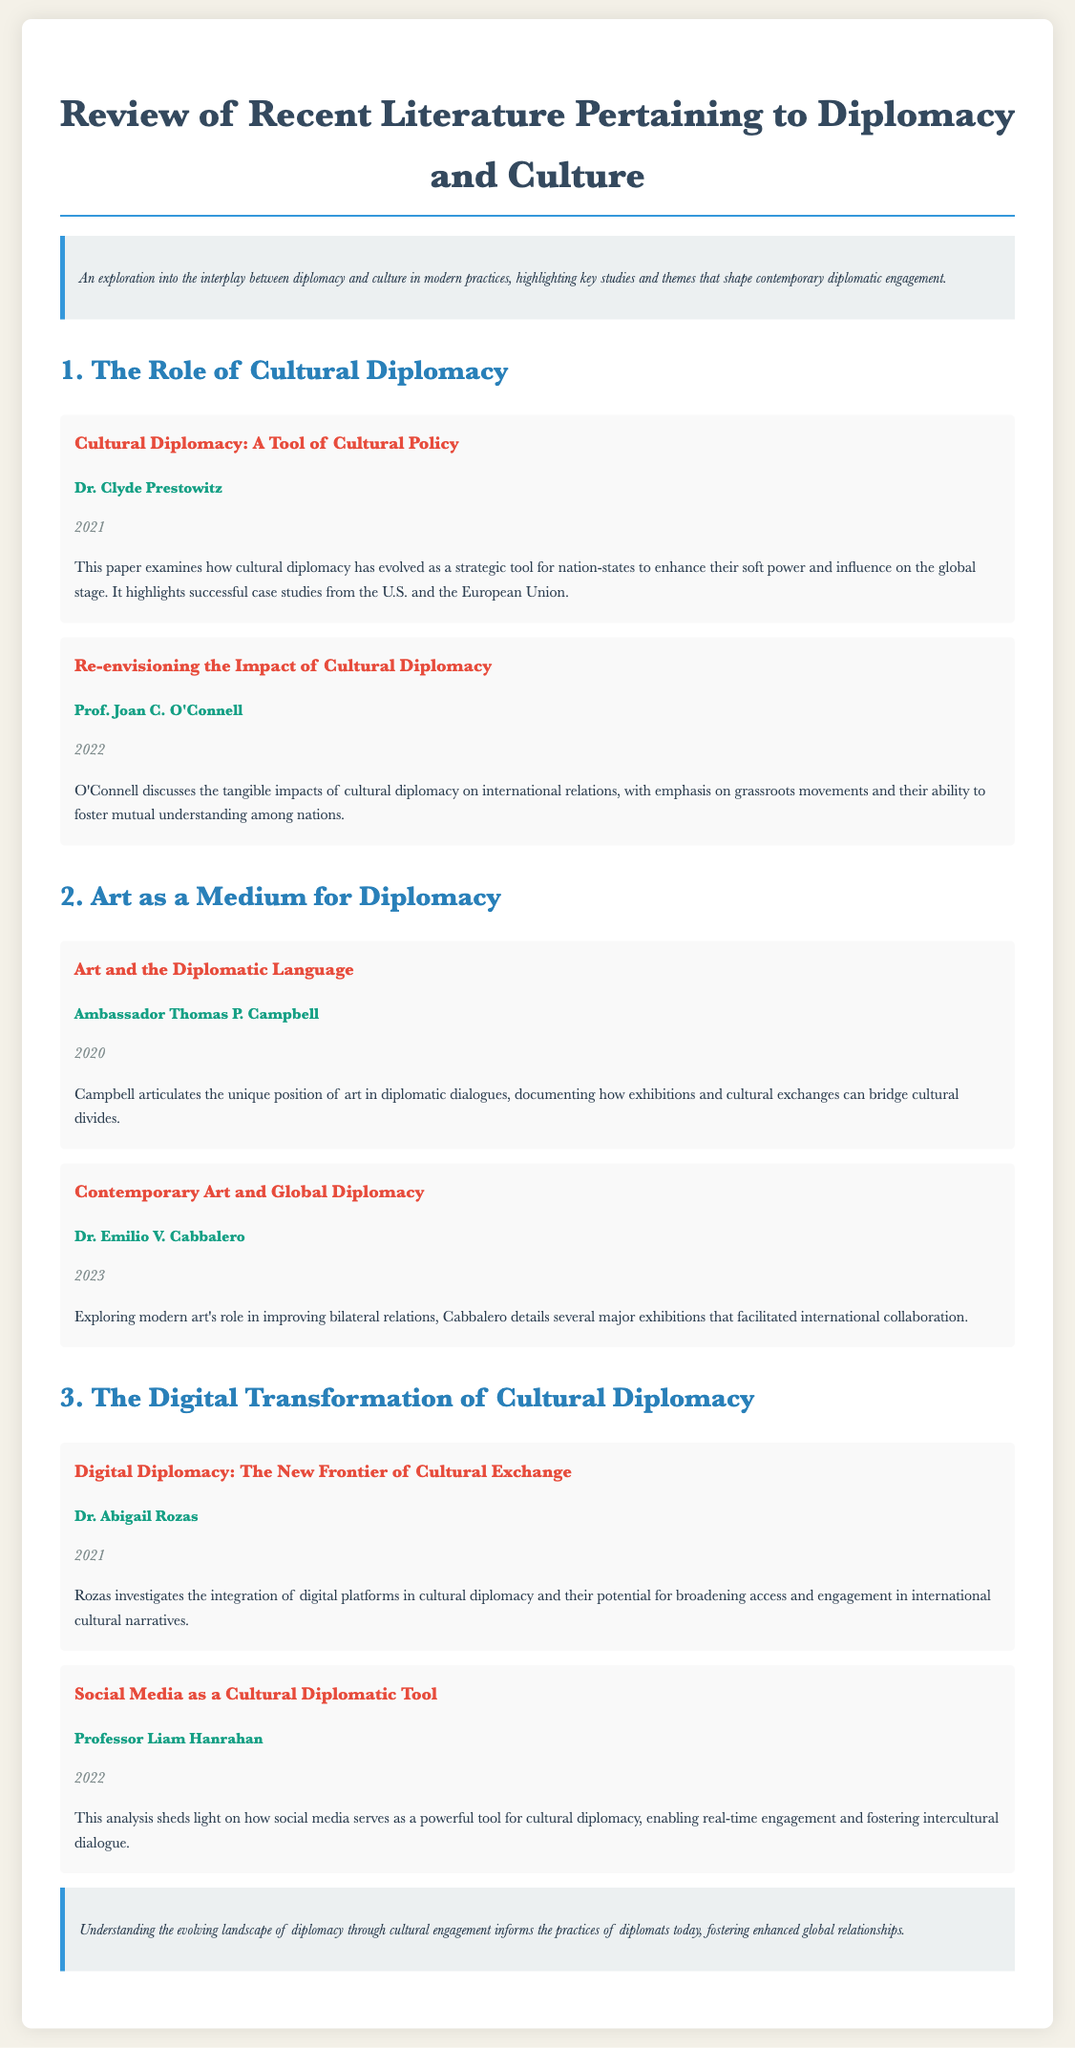What is the title of the document? The title of the document is prominently displayed at the top, summarizing its focus.
Answer: Review of Recent Literature Pertaining to Diplomacy and Culture Who authored the paper "Digital Diplomacy: The New Frontier of Cultural Exchange"? This information is provided in the section detailing authors of various papers within the document.
Answer: Dr. Abigail Rozas In what year was "Contemporary Art and Global Diplomacy" published? The publication year for this paper is listed alongside its title.
Answer: 2023 What theme does Dr. Clyde Prestowitz's paper primarily discuss? The paper focuses on how cultural diplomacy serves as a strategic tool for enhancing soft power.
Answer: Cultural diplomacy Which medium does Ambassador Thomas P. Campbell emphasize as crucial in diplomatic dialogues? The section on art discusses its position as a unique bridge in diplomatic conversations.
Answer: Art What is the primary focus of Professor Liam Hanrahan's analysis? The document outlines how social media is being utilized in cultural diplomacy.
Answer: Social media Identify a case study type mentioned in the document that emphasizes grassroots movements. The document references tangible impacts of cultural diplomacy particularly through community efforts.
Answer: Grassroots movements What is a significant implication of understanding cultural engagement for modern diplomats? Insights from cultural diplomacy shape how diplomatic relationships are built today.
Answer: Enhanced global relationships 